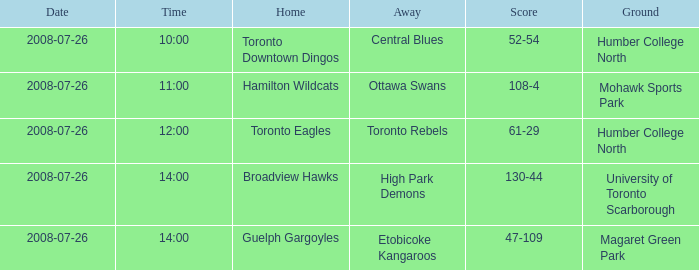The Away High Park Demons was which Ground? University of Toronto Scarborough. 